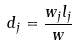<formula> <loc_0><loc_0><loc_500><loc_500>d _ { j } = \frac { w _ { j } l _ { j } } { w }</formula> 